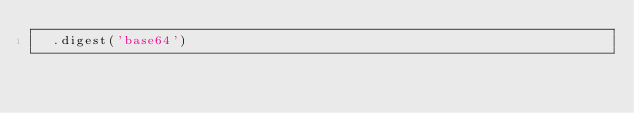Convert code to text. <code><loc_0><loc_0><loc_500><loc_500><_JavaScript_>  .digest('base64')
</code> 